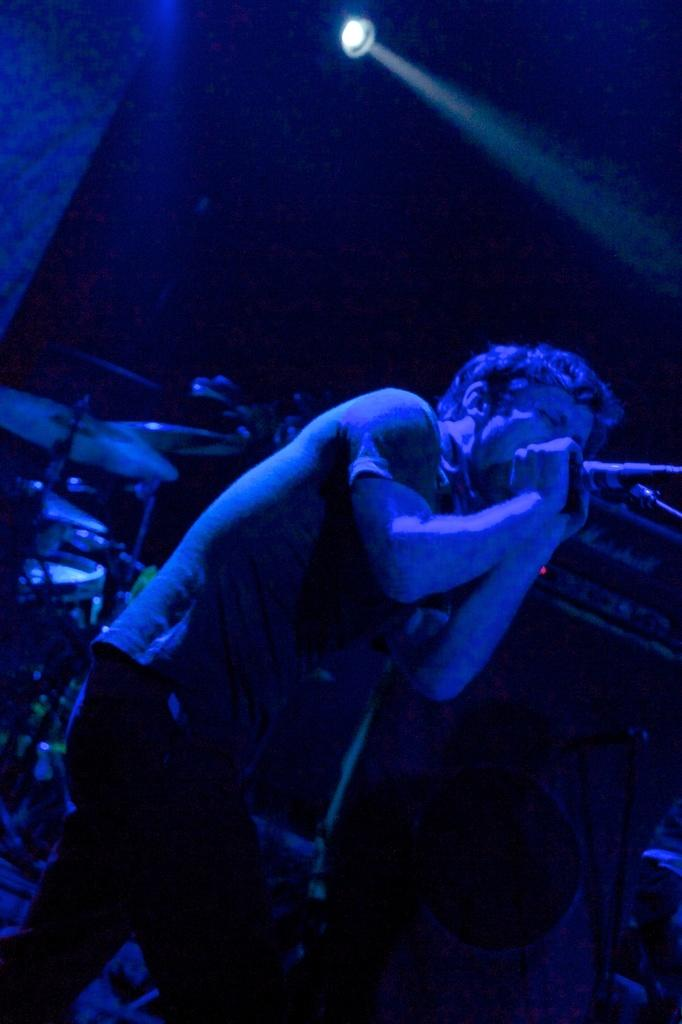Who is the main subject in the image? There is a person in the image. What is the person holding in the image? The person is holding a mic. What is the person doing with the mic? The person is singing. What other objects are present in the image? There are musical instruments and a focus light in the image. What type of wool is being used to create the melody in the image? There is no wool present in the image, and the melody is created by the person singing and the musical instruments. 